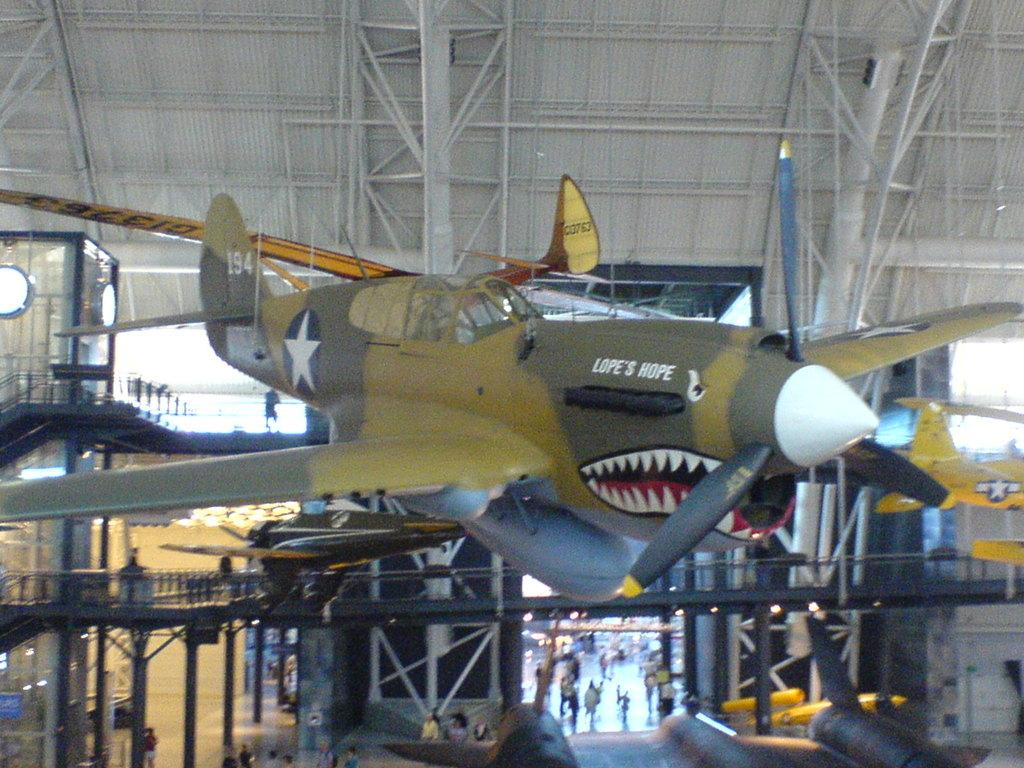Provide a one-sentence caption for the provided image. The airplane named "Lope's Hope" is suspended in air in a hangar. 